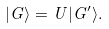Convert formula to latex. <formula><loc_0><loc_0><loc_500><loc_500>| G \rangle = U | G ^ { \prime } \rangle .</formula> 